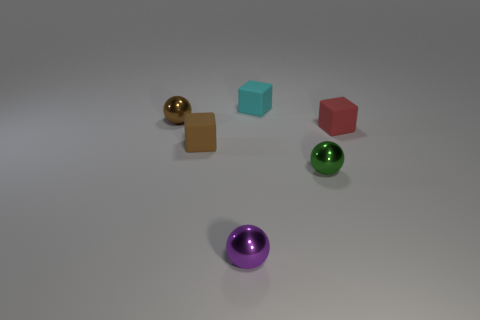Subtract all brown shiny spheres. How many spheres are left? 2 Add 2 yellow rubber cubes. How many objects exist? 8 Subtract 1 spheres. How many spheres are left? 2 Subtract all gray balls. Subtract all red blocks. How many balls are left? 3 Subtract all tiny purple metal spheres. Subtract all purple metallic objects. How many objects are left? 4 Add 1 tiny brown objects. How many tiny brown objects are left? 3 Add 2 green objects. How many green objects exist? 3 Subtract 0 gray blocks. How many objects are left? 6 